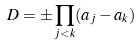Convert formula to latex. <formula><loc_0><loc_0><loc_500><loc_500>D = \pm \prod _ { j < k } ( a _ { j } - a _ { k } )</formula> 